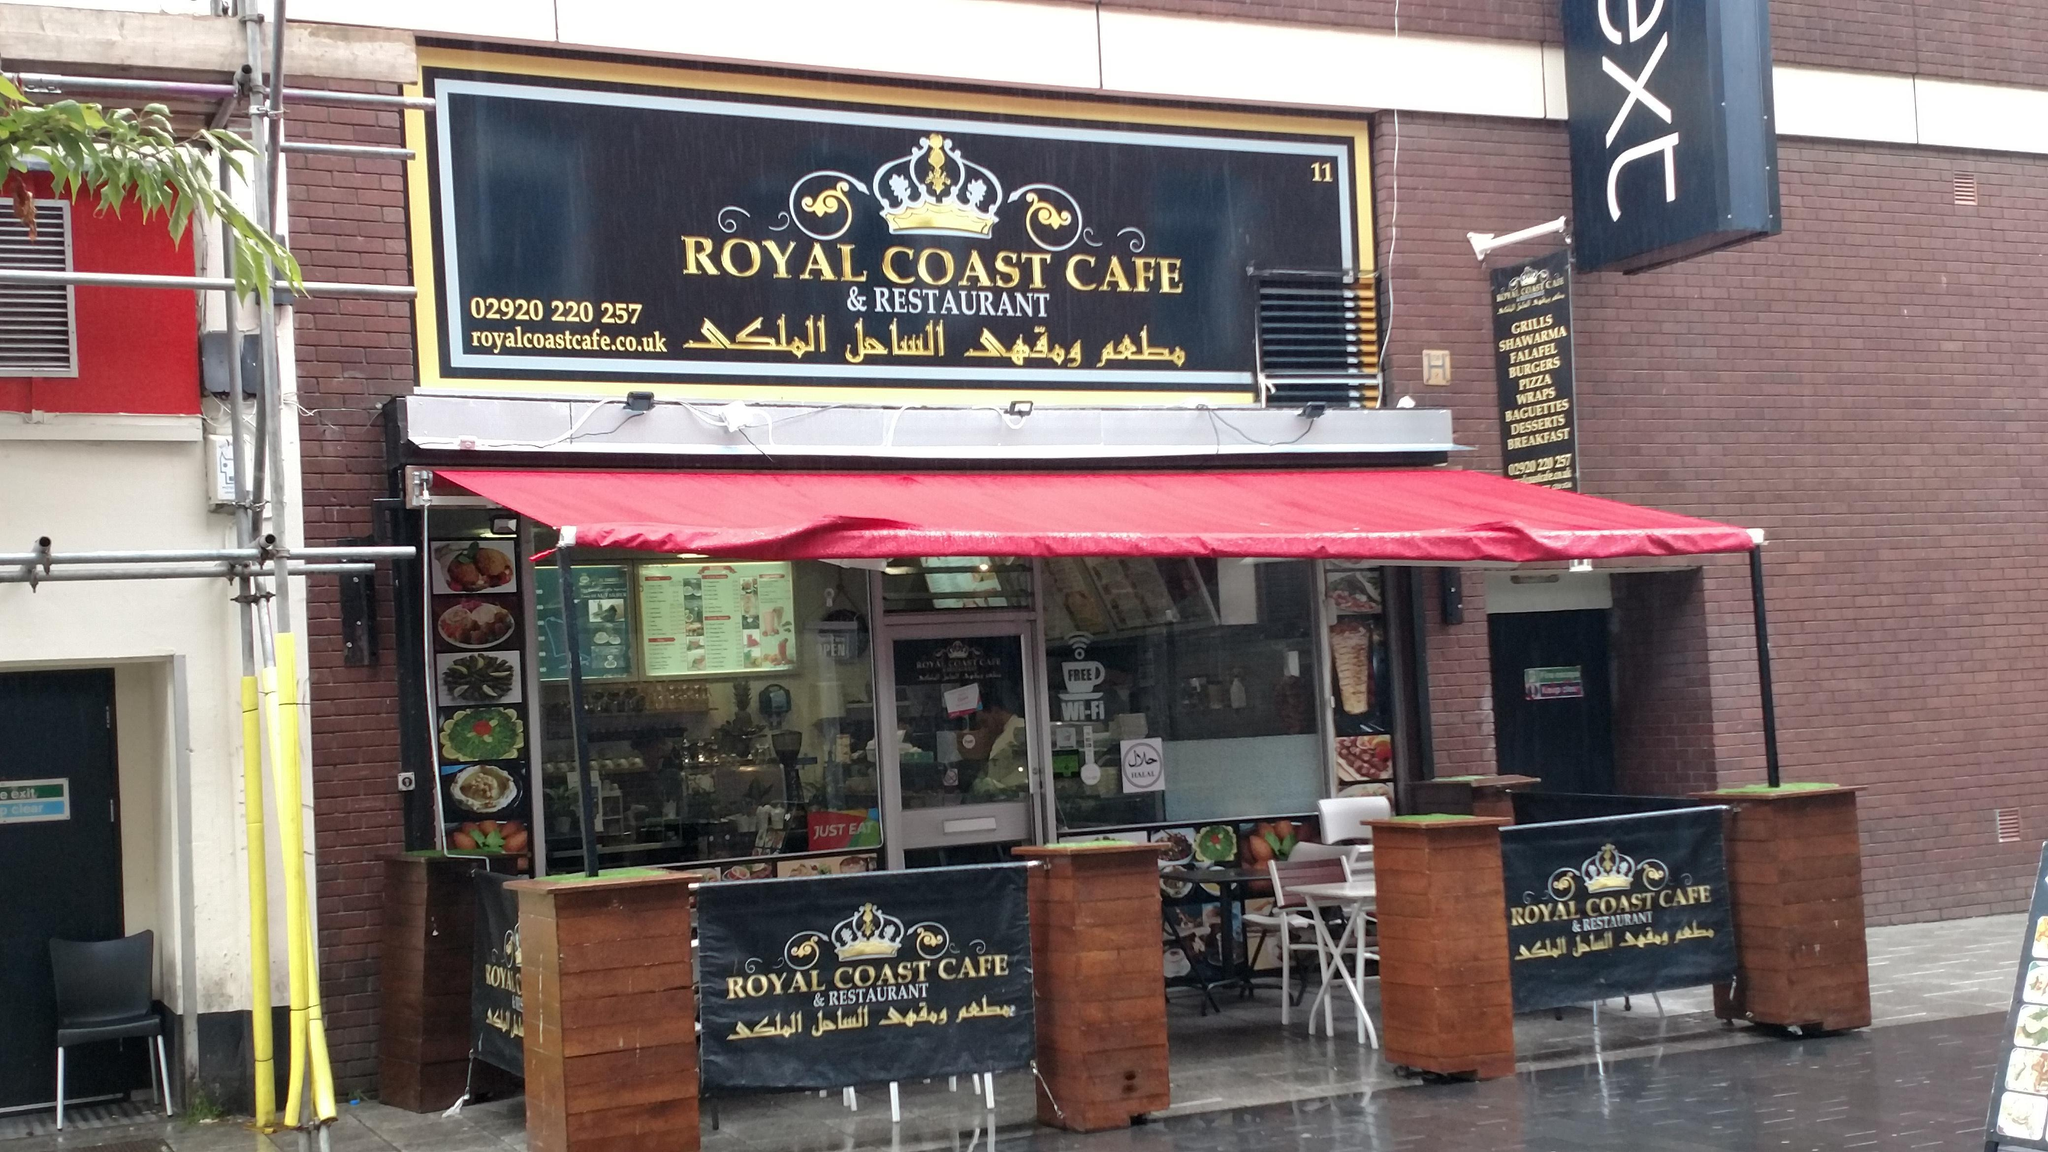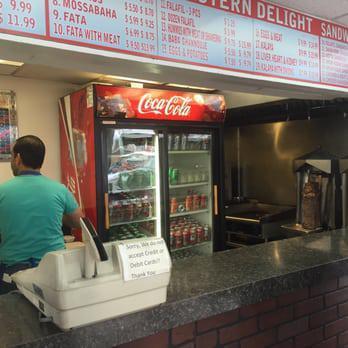The first image is the image on the left, the second image is the image on the right. Evaluate the accuracy of this statement regarding the images: "One of the restaurants serves pizza.". Is it true? Answer yes or no. No. The first image is the image on the left, the second image is the image on the right. For the images displayed, is the sentence "There are tables under the awning in one image." factually correct? Answer yes or no. Yes. 